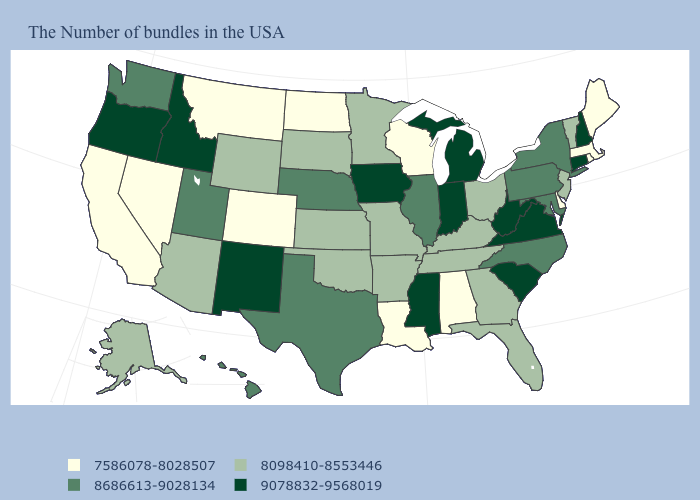What is the lowest value in the USA?
Answer briefly. 7586078-8028507. What is the value of Nebraska?
Keep it brief. 8686613-9028134. Among the states that border West Virginia , which have the highest value?
Give a very brief answer. Virginia. Which states have the highest value in the USA?
Short answer required. New Hampshire, Connecticut, Virginia, South Carolina, West Virginia, Michigan, Indiana, Mississippi, Iowa, New Mexico, Idaho, Oregon. Does New Hampshire have the highest value in the USA?
Answer briefly. Yes. What is the highest value in the Northeast ?
Quick response, please. 9078832-9568019. Among the states that border Missouri , does Illinois have the lowest value?
Keep it brief. No. What is the value of Hawaii?
Short answer required. 8686613-9028134. Among the states that border Virginia , does West Virginia have the highest value?
Keep it brief. Yes. What is the value of Florida?
Answer briefly. 8098410-8553446. What is the value of Washington?
Write a very short answer. 8686613-9028134. Does the map have missing data?
Be succinct. No. What is the value of South Dakota?
Concise answer only. 8098410-8553446. Does Hawaii have the highest value in the West?
Answer briefly. No. Name the states that have a value in the range 8686613-9028134?
Short answer required. New York, Maryland, Pennsylvania, North Carolina, Illinois, Nebraska, Texas, Utah, Washington, Hawaii. 